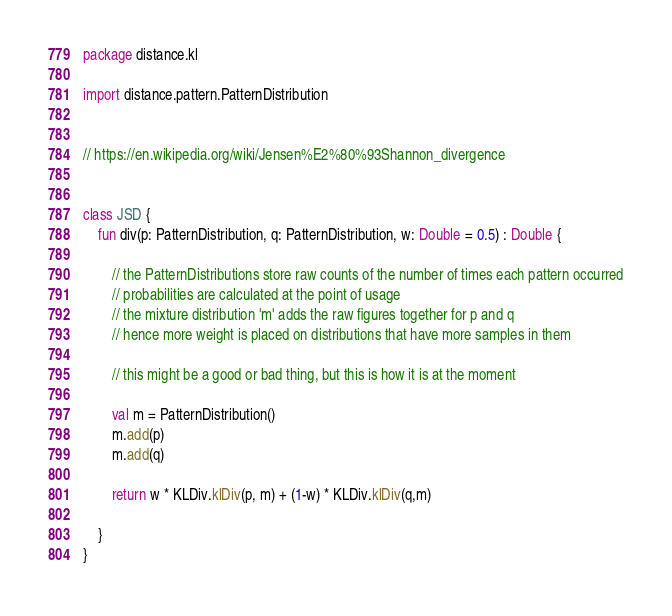Convert code to text. <code><loc_0><loc_0><loc_500><loc_500><_Kotlin_>package distance.kl

import distance.pattern.PatternDistribution


// https://en.wikipedia.org/wiki/Jensen%E2%80%93Shannon_divergence


class JSD {
    fun div(p: PatternDistribution, q: PatternDistribution, w: Double = 0.5) : Double {

        // the PatternDistributions store raw counts of the number of times each pattern occurred
        // probabilities are calculated at the point of usage
        // the mixture distribution 'm' adds the raw figures together for p and q
        // hence more weight is placed on distributions that have more samples in them

        // this might be a good or bad thing, but this is how it is at the moment

        val m = PatternDistribution()
        m.add(p)
        m.add(q)

        return w * KLDiv.klDiv(p, m) + (1-w) * KLDiv.klDiv(q,m)

    }
}

</code> 